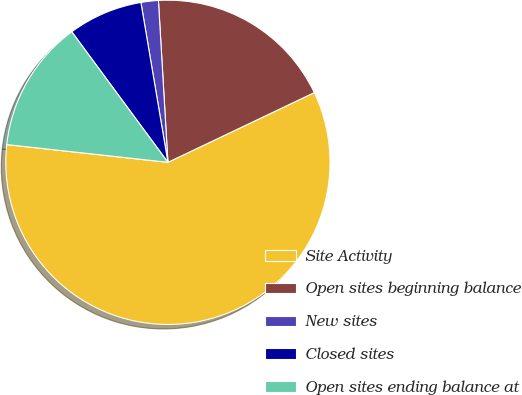<chart> <loc_0><loc_0><loc_500><loc_500><pie_chart><fcel>Site Activity<fcel>Open sites beginning balance<fcel>New sites<fcel>Closed sites<fcel>Open sites ending balance at<nl><fcel>58.82%<fcel>18.86%<fcel>1.73%<fcel>7.44%<fcel>13.15%<nl></chart> 